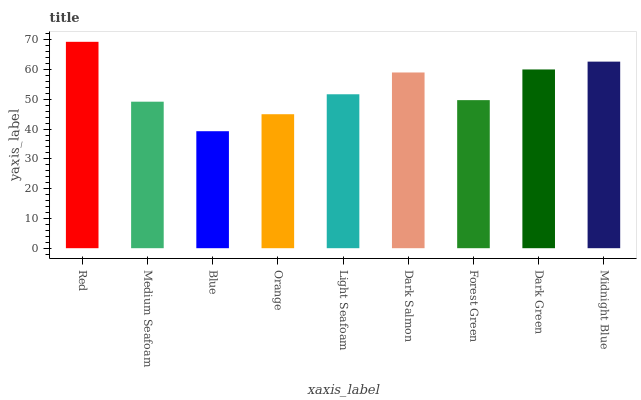Is Medium Seafoam the minimum?
Answer yes or no. No. Is Medium Seafoam the maximum?
Answer yes or no. No. Is Red greater than Medium Seafoam?
Answer yes or no. Yes. Is Medium Seafoam less than Red?
Answer yes or no. Yes. Is Medium Seafoam greater than Red?
Answer yes or no. No. Is Red less than Medium Seafoam?
Answer yes or no. No. Is Light Seafoam the high median?
Answer yes or no. Yes. Is Light Seafoam the low median?
Answer yes or no. Yes. Is Medium Seafoam the high median?
Answer yes or no. No. Is Blue the low median?
Answer yes or no. No. 